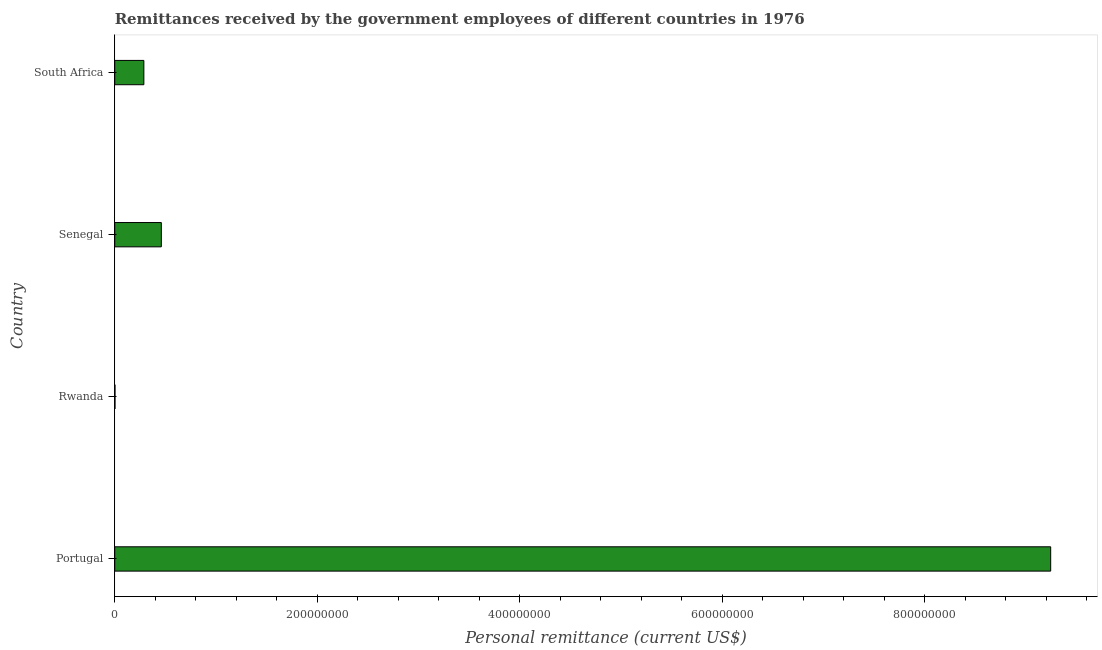Does the graph contain any zero values?
Offer a terse response. No. What is the title of the graph?
Make the answer very short. Remittances received by the government employees of different countries in 1976. What is the label or title of the X-axis?
Offer a very short reply. Personal remittance (current US$). What is the label or title of the Y-axis?
Provide a short and direct response. Country. What is the personal remittances in Rwanda?
Give a very brief answer. 2.47e+05. Across all countries, what is the maximum personal remittances?
Make the answer very short. 9.24e+08. Across all countries, what is the minimum personal remittances?
Offer a terse response. 2.47e+05. In which country was the personal remittances minimum?
Your answer should be compact. Rwanda. What is the sum of the personal remittances?
Ensure brevity in your answer.  9.99e+08. What is the difference between the personal remittances in Portugal and Rwanda?
Ensure brevity in your answer.  9.24e+08. What is the average personal remittances per country?
Offer a very short reply. 2.50e+08. What is the median personal remittances?
Offer a terse response. 3.74e+07. In how many countries, is the personal remittances greater than 200000000 US$?
Ensure brevity in your answer.  1. What is the ratio of the personal remittances in Rwanda to that in Senegal?
Your answer should be very brief. 0.01. What is the difference between the highest and the second highest personal remittances?
Make the answer very short. 8.78e+08. Is the sum of the personal remittances in Rwanda and South Africa greater than the maximum personal remittances across all countries?
Your response must be concise. No. What is the difference between the highest and the lowest personal remittances?
Your answer should be compact. 9.24e+08. In how many countries, is the personal remittances greater than the average personal remittances taken over all countries?
Provide a succinct answer. 1. How many bars are there?
Keep it short and to the point. 4. What is the Personal remittance (current US$) of Portugal?
Ensure brevity in your answer.  9.24e+08. What is the Personal remittance (current US$) in Rwanda?
Your response must be concise. 2.47e+05. What is the Personal remittance (current US$) of Senegal?
Ensure brevity in your answer.  4.60e+07. What is the Personal remittance (current US$) of South Africa?
Give a very brief answer. 2.88e+07. What is the difference between the Personal remittance (current US$) in Portugal and Rwanda?
Give a very brief answer. 9.24e+08. What is the difference between the Personal remittance (current US$) in Portugal and Senegal?
Give a very brief answer. 8.78e+08. What is the difference between the Personal remittance (current US$) in Portugal and South Africa?
Offer a very short reply. 8.96e+08. What is the difference between the Personal remittance (current US$) in Rwanda and Senegal?
Keep it short and to the point. -4.57e+07. What is the difference between the Personal remittance (current US$) in Rwanda and South Africa?
Your answer should be compact. -2.85e+07. What is the difference between the Personal remittance (current US$) in Senegal and South Africa?
Provide a short and direct response. 1.72e+07. What is the ratio of the Personal remittance (current US$) in Portugal to that in Rwanda?
Your answer should be compact. 3736.35. What is the ratio of the Personal remittance (current US$) in Portugal to that in Senegal?
Provide a short and direct response. 20.1. What is the ratio of the Personal remittance (current US$) in Portugal to that in South Africa?
Your response must be concise. 32.15. What is the ratio of the Personal remittance (current US$) in Rwanda to that in Senegal?
Provide a short and direct response. 0.01. What is the ratio of the Personal remittance (current US$) in Rwanda to that in South Africa?
Keep it short and to the point. 0.01. What is the ratio of the Personal remittance (current US$) in Senegal to that in South Africa?
Provide a succinct answer. 1.6. 